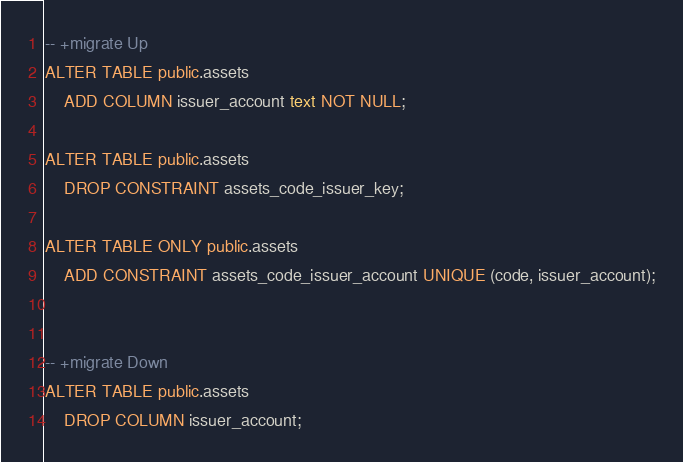Convert code to text. <code><loc_0><loc_0><loc_500><loc_500><_SQL_>
-- +migrate Up
ALTER TABLE public.assets
    ADD COLUMN issuer_account text NOT NULL;

ALTER TABLE public.assets
    DROP CONSTRAINT assets_code_issuer_key;

ALTER TABLE ONLY public.assets
    ADD CONSTRAINT assets_code_issuer_account UNIQUE (code, issuer_account);


-- +migrate Down
ALTER TABLE public.assets
    DROP COLUMN issuer_account;
</code> 